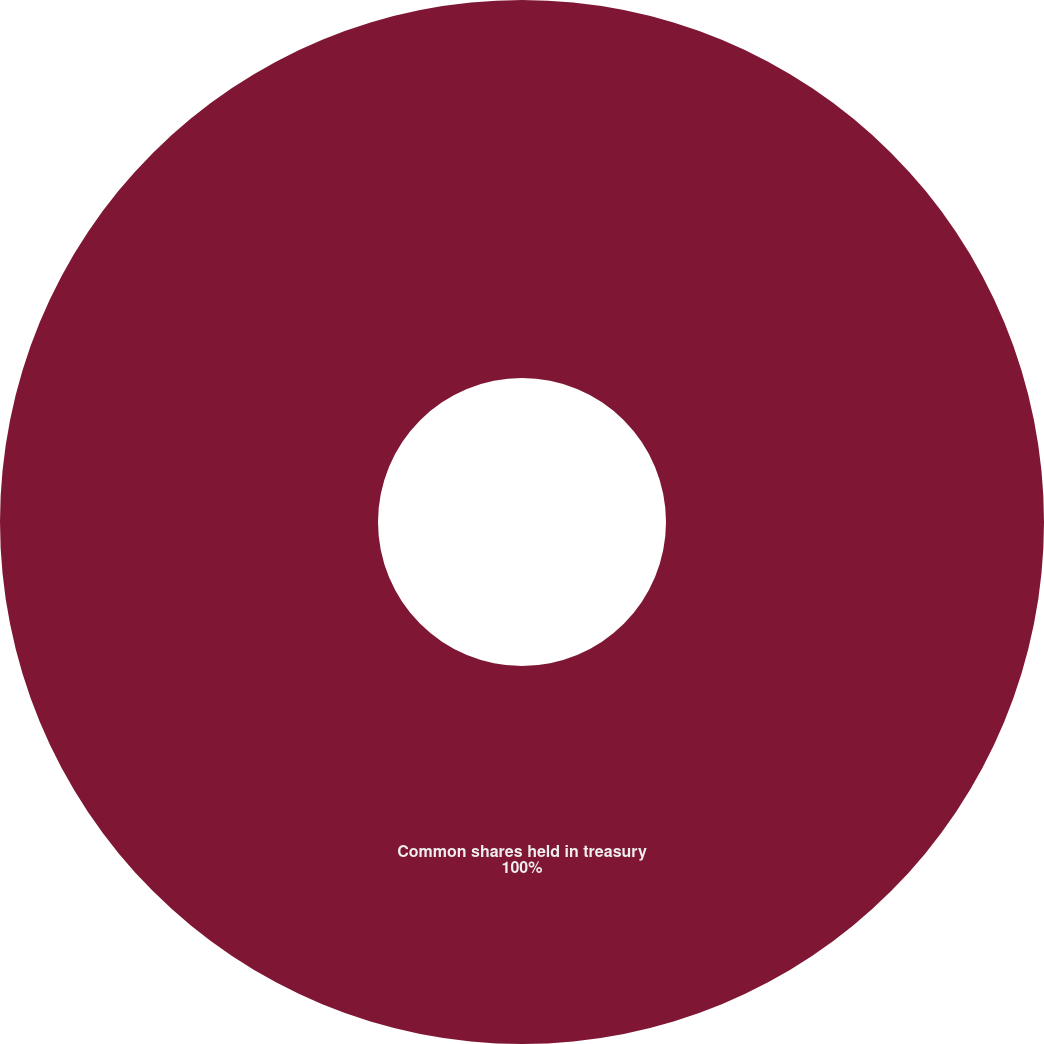<chart> <loc_0><loc_0><loc_500><loc_500><pie_chart><fcel>Common shares held in treasury<nl><fcel>100.0%<nl></chart> 